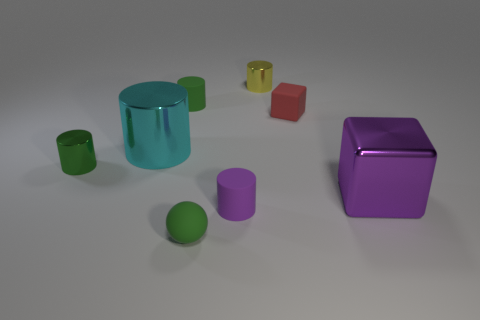Subtract all yellow cylinders. How many cylinders are left? 4 Subtract all yellow shiny cylinders. How many cylinders are left? 4 Subtract all gray cylinders. Subtract all purple cubes. How many cylinders are left? 5 Add 2 big cyan metallic cylinders. How many objects exist? 10 Subtract all spheres. How many objects are left? 7 Add 2 purple things. How many purple things exist? 4 Subtract 0 yellow cubes. How many objects are left? 8 Subtract all large purple shiny blocks. Subtract all rubber balls. How many objects are left? 6 Add 1 purple matte objects. How many purple matte objects are left? 2 